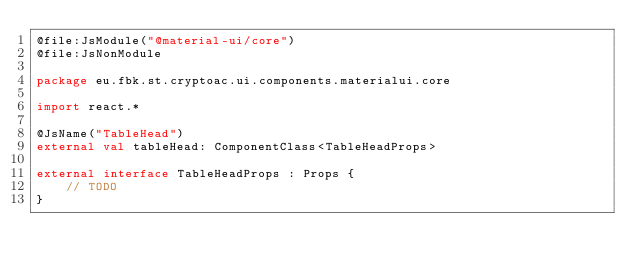Convert code to text. <code><loc_0><loc_0><loc_500><loc_500><_Kotlin_>@file:JsModule("@material-ui/core")
@file:JsNonModule

package eu.fbk.st.cryptoac.ui.components.materialui.core

import react.*

@JsName("TableHead")
external val tableHead: ComponentClass<TableHeadProps>

external interface TableHeadProps : Props {
    // TODO
}</code> 